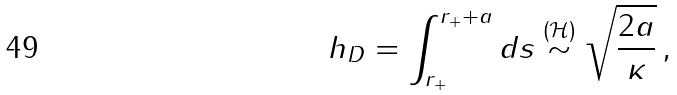Convert formula to latex. <formula><loc_0><loc_0><loc_500><loc_500>h _ { D } = \int _ { r _ { + } } ^ { r _ { + } + a } d s \stackrel { ( \mathcal { H } ) } { \sim } \sqrt { \frac { 2 a } { \kappa } } \, ,</formula> 